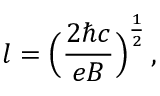<formula> <loc_0><loc_0><loc_500><loc_500>l = \left ( { \frac { 2 \hbar { c } } { e B } } \right ) ^ { \frac { 1 } { 2 } } \, ,</formula> 